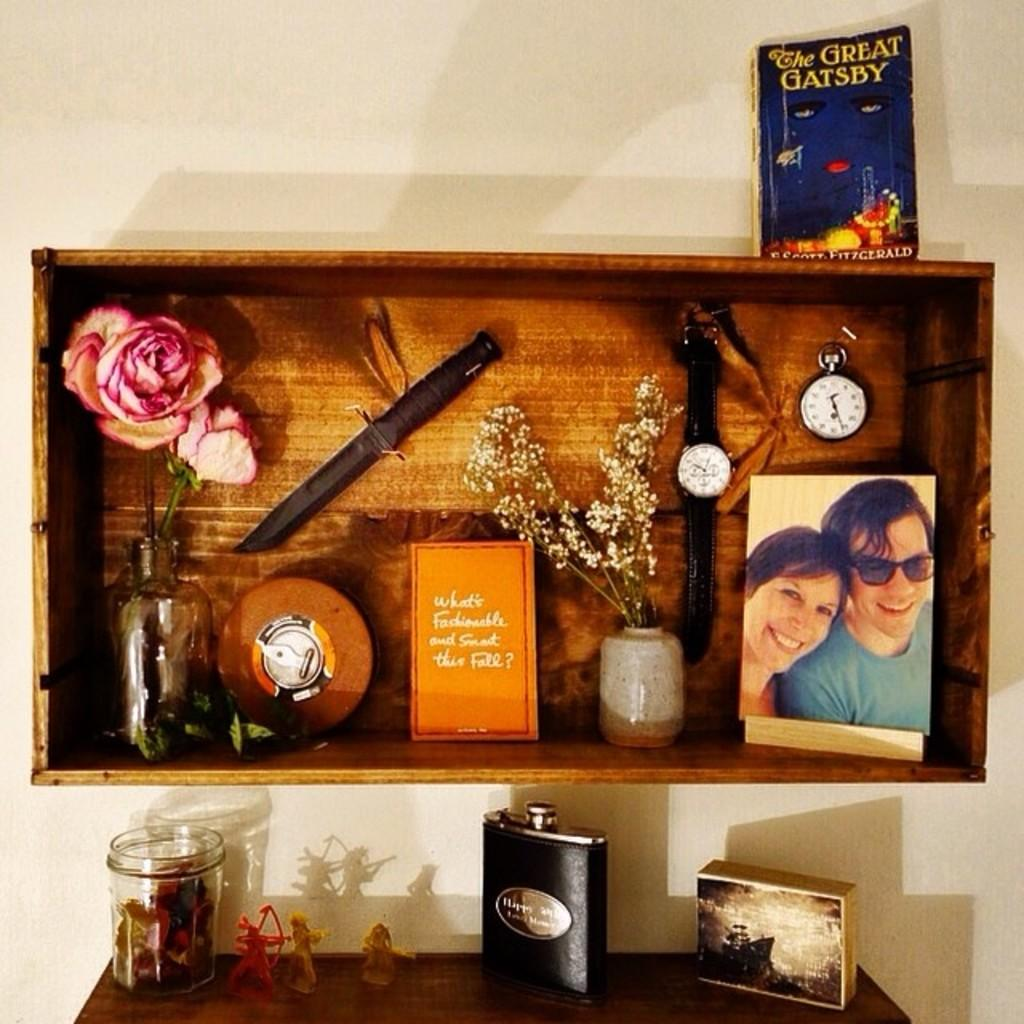Provide a one-sentence caption for the provided image. A shelf with the Great Gatsby well looking read book on top. 